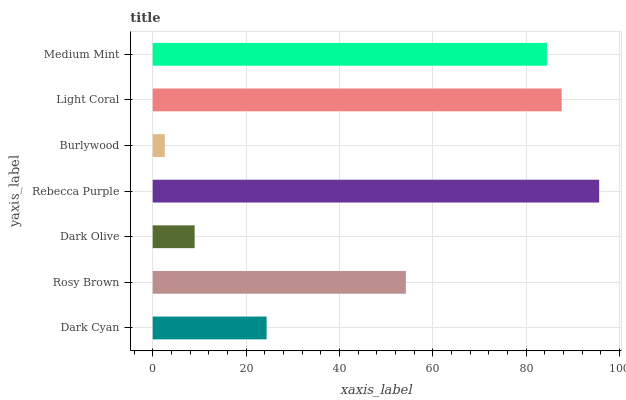Is Burlywood the minimum?
Answer yes or no. Yes. Is Rebecca Purple the maximum?
Answer yes or no. Yes. Is Rosy Brown the minimum?
Answer yes or no. No. Is Rosy Brown the maximum?
Answer yes or no. No. Is Rosy Brown greater than Dark Cyan?
Answer yes or no. Yes. Is Dark Cyan less than Rosy Brown?
Answer yes or no. Yes. Is Dark Cyan greater than Rosy Brown?
Answer yes or no. No. Is Rosy Brown less than Dark Cyan?
Answer yes or no. No. Is Rosy Brown the high median?
Answer yes or no. Yes. Is Rosy Brown the low median?
Answer yes or no. Yes. Is Burlywood the high median?
Answer yes or no. No. Is Burlywood the low median?
Answer yes or no. No. 